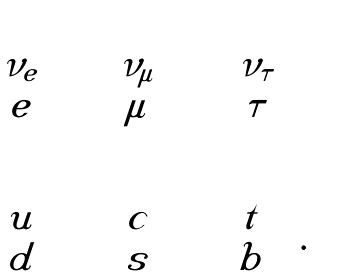Convert formula to latex. <formula><loc_0><loc_0><loc_500><loc_500>\begin{array} { c c c } \left ( \begin{array} { c } \nu _ { e } \\ e \end{array} \right ) & \left ( \begin{array} { c } \nu _ { \mu } \\ \mu \end{array} \right ) & \left ( \begin{array} { c } \nu _ { \tau } \\ \tau \end{array} \right ) \\ \\ \left ( \begin{array} { c } u \\ d \end{array} \right ) & \left ( \begin{array} { c } c \\ s \end{array} \right ) & \left ( \begin{array} { c } t \\ b \end{array} \right ) . \end{array}</formula> 